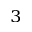<formula> <loc_0><loc_0><loc_500><loc_500>^ { 3 }</formula> 